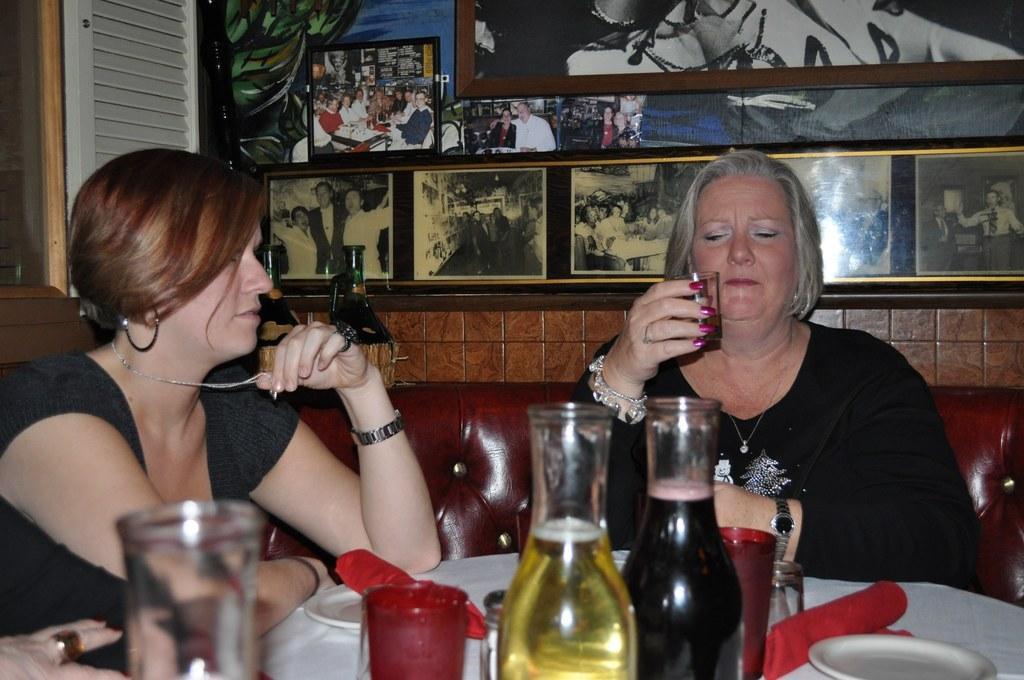Can you describe this image briefly? On the background we can see photo frames over a wall. Here we can see one woman sitting on a chair and holding a glass in her hand. This woman sitting on a chair and she is holding a chain in her hands. She wore watch. On the table we can see plates, table mats, galsses with liquids in it. 